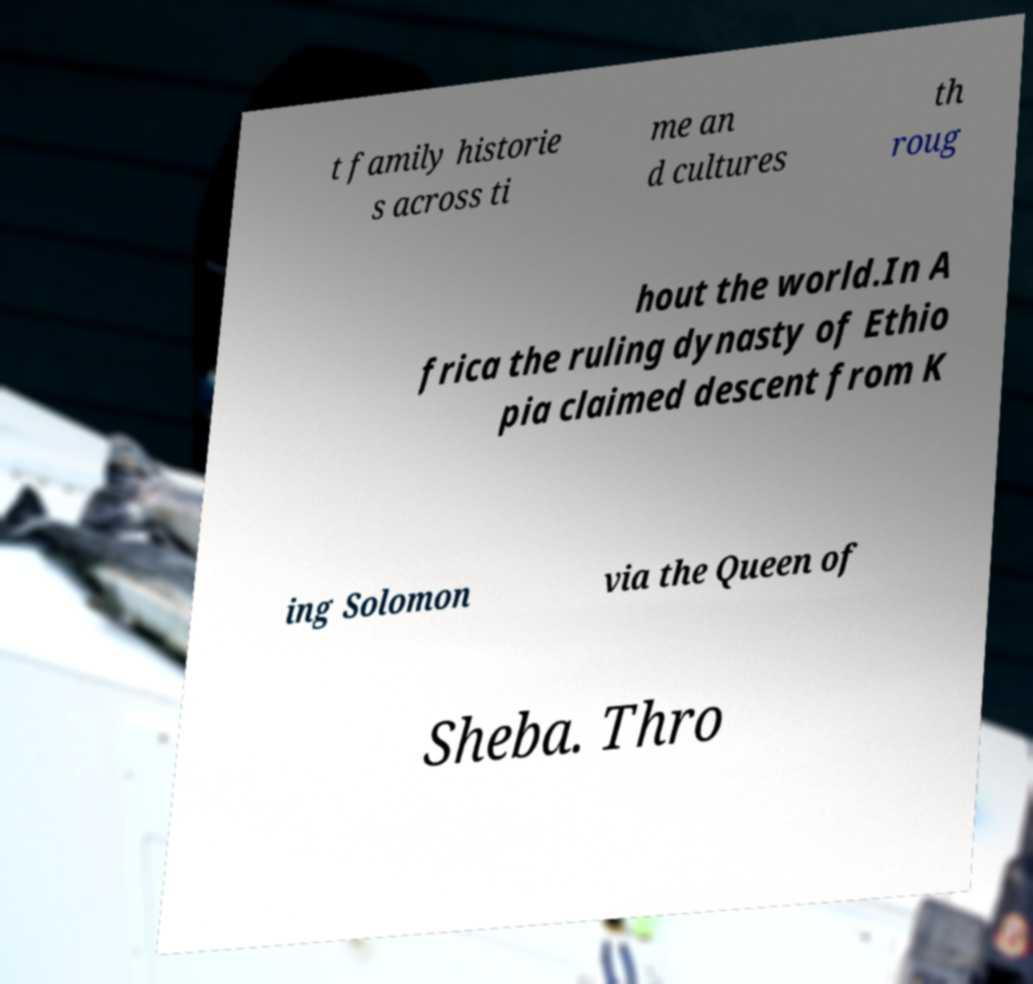What messages or text are displayed in this image? I need them in a readable, typed format. t family historie s across ti me an d cultures th roug hout the world.In A frica the ruling dynasty of Ethio pia claimed descent from K ing Solomon via the Queen of Sheba. Thro 